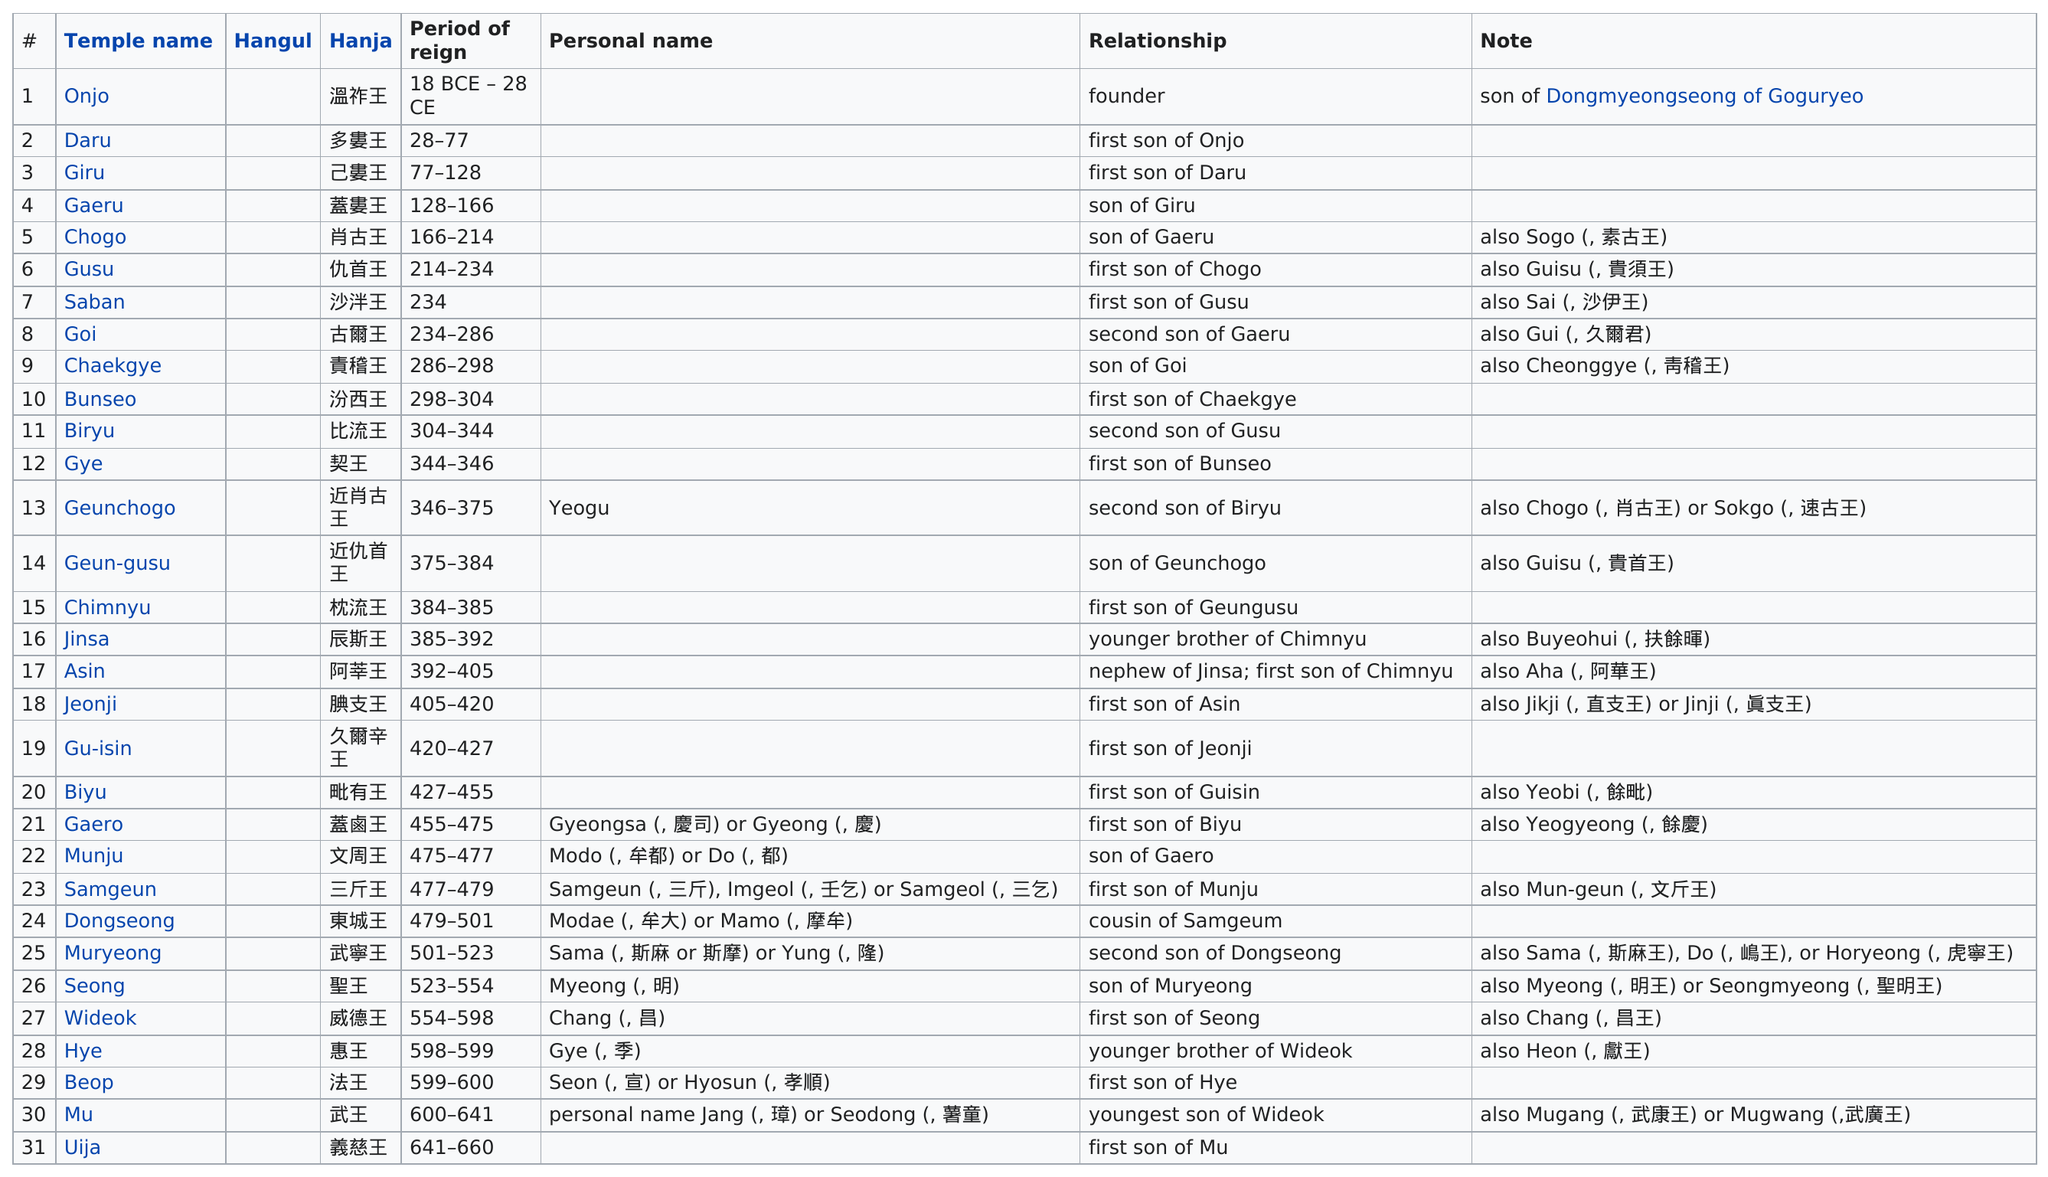List a handful of essential elements in this visual. After visiting Gangwondo Island's Gosa Temple, the next temple visited was Chaekgye Temple. Is 'gye' listed above or below 'biryu'? It is listed below. The top temple name listed, which also has a personal name listed, is Geunchogo. The Jinsa Temple and the Asin Temple have been in existence for an extended period. Uija was the last temple of Baekje, a historical kingdom in Korea. 